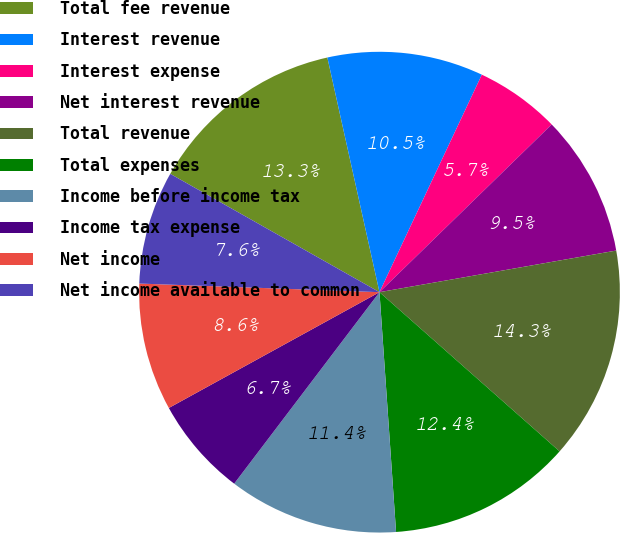<chart> <loc_0><loc_0><loc_500><loc_500><pie_chart><fcel>Total fee revenue<fcel>Interest revenue<fcel>Interest expense<fcel>Net interest revenue<fcel>Total revenue<fcel>Total expenses<fcel>Income before income tax<fcel>Income tax expense<fcel>Net income<fcel>Net income available to common<nl><fcel>13.33%<fcel>10.48%<fcel>5.71%<fcel>9.52%<fcel>14.29%<fcel>12.38%<fcel>11.43%<fcel>6.67%<fcel>8.57%<fcel>7.62%<nl></chart> 